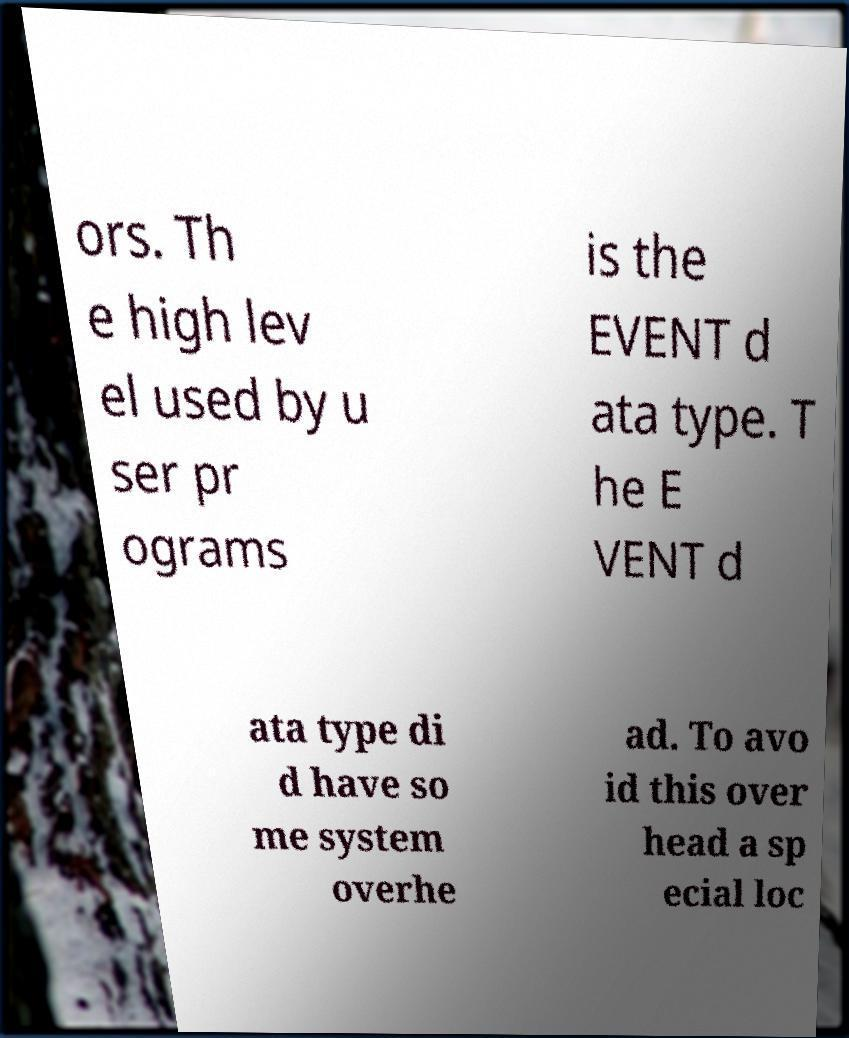For documentation purposes, I need the text within this image transcribed. Could you provide that? ors. Th e high lev el used by u ser pr ograms is the EVENT d ata type. T he E VENT d ata type di d have so me system overhe ad. To avo id this over head a sp ecial loc 